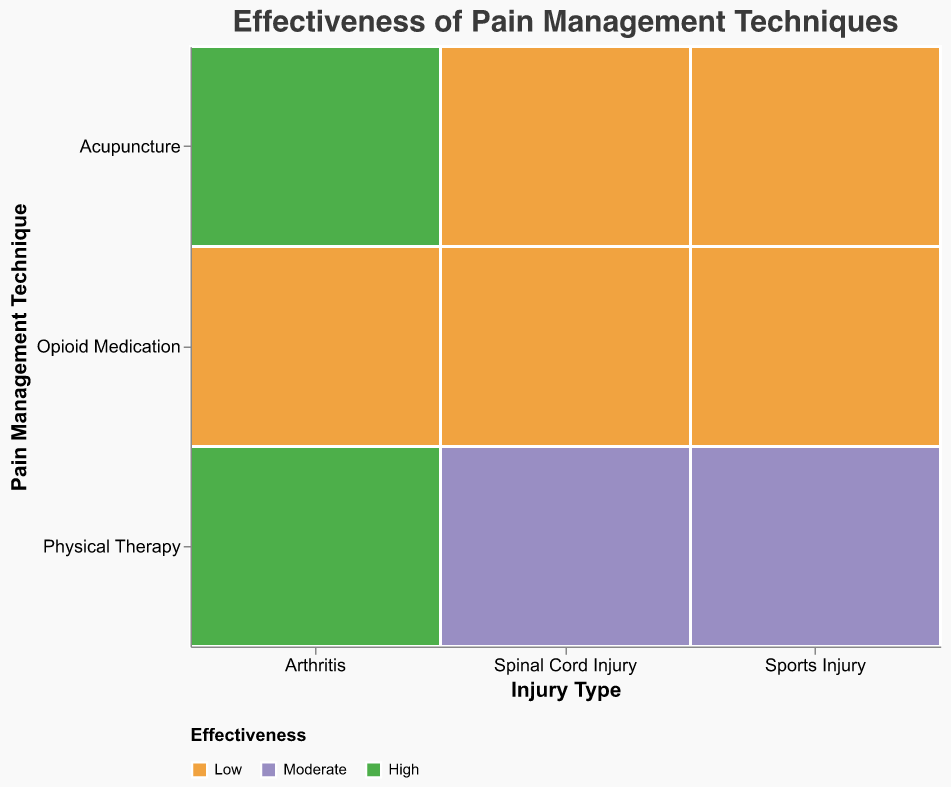What is the title of the figure? The title of the figure is located at the top and states the main subject of the visualization. The figure's title is "Effectiveness of Pain Management Techniques."
Answer: Effectiveness of Pain Management Techniques Which Pain Management Technique appears to be the most effective for young (18-35) patients with Spinal Cord Injury? To find this, look at the "Spinal Cord Injury" x-axis category, then examine the "18-35" patient age group in the size legend, and check the effectiveness indicated by the color. "Physical Therapy" is colored in the "High" effectiveness color.
Answer: Physical Therapy Which Injury Type shows high effectiveness of Acupuncture for the older (56+) age group? Locate the "Acupuncture" y-axis category, then check the size legend for the "56+" age group across all injury types. For "Arthritis," the color corresponds to "High" effectiveness.
Answer: Arthritis Is Physical Therapy effective for older patients (56+) with Arthritis? To determine this, look at the "Arthritis" x-axis category, and then find "Physical Therapy" in the y-axis category, checking the 56+ age group size and color-coded effectiveness, which is high.
Answer: Yes Which age group finds Opioid Medication least effective in managing pain from Sports Injury? Look at the "Sports Injury" x-axis category, find "Opioid Medication" under the y-axis, and check the color effectiveness for the patient age groups. The "56+" age group has the color for "Low" effectiveness.
Answer: 56+ How does the effectiveness of Acupuncture compare for 18-35 age group patients with Spinal Cord Injury versus Arthritis? Compare the "Acupuncture" y-axis category under "Spinal Cord Injury" and "Arthritis" x-axis categories for the effectiveness color of the "18-35" age group. Sspinal Cord Injury" shows "Moderate" whereas "Arthritis" shows "Low" effectiveness.
Answer: Spinal Cord Injury has higher effectiveness What is the most effective Pain Management Technique for patients aged 36-55 with Sports Injury? To answer this, look at the "Sports Injury" x-axis category, then find the 36-55 age group size across all techniques, and check the effectiveness colors. "Physical Therapy" shows high effectiveness.
Answer: Physical Therapy Do any Injury Types show high effectiveness of Opioid Medication for older patients (56+)? Examine the "Opioid Medication" y-axis category under all injury types, especially the 56+ age group size and color-coded effectiveness. None of the effectiveness values for "56+" are high.
Answer: No For which Injury Type is Physical Therapy moderately effective for the older age group (56+)? Check the "Physical Therapy" y-axis category for the "56+" age group size and color-coded effectiveness. Both "Spinal Cord Injury" and "Sports Injury" are colored in "Moderate" effectiveness.
Answer: Spinal Cord Injury, Sports Injury What is the least effective Pain Management Technique for middle-aged (36-55) patients with Arthritis? Look in the "Arthritis" x-axis category, then check the 36-55 age group size across all techniques for the least effective color. "Acupuncture" is marked as "Moderate" compared to the others.
Answer: Acupuncture 